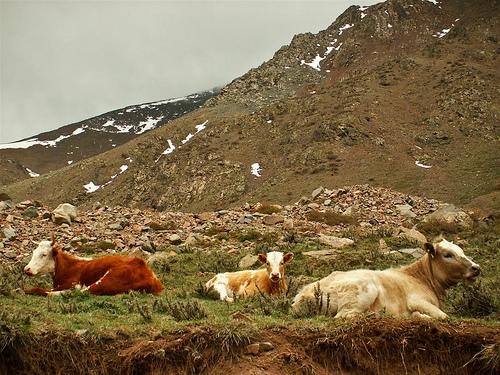What kind of animals are these?
Quick response, please. Cows. How many cows are standing?
Give a very brief answer. 0. What kind of climate do these cows live in?
Write a very short answer. Cold. Is that a red Angus cow?
Give a very brief answer. Yes. 